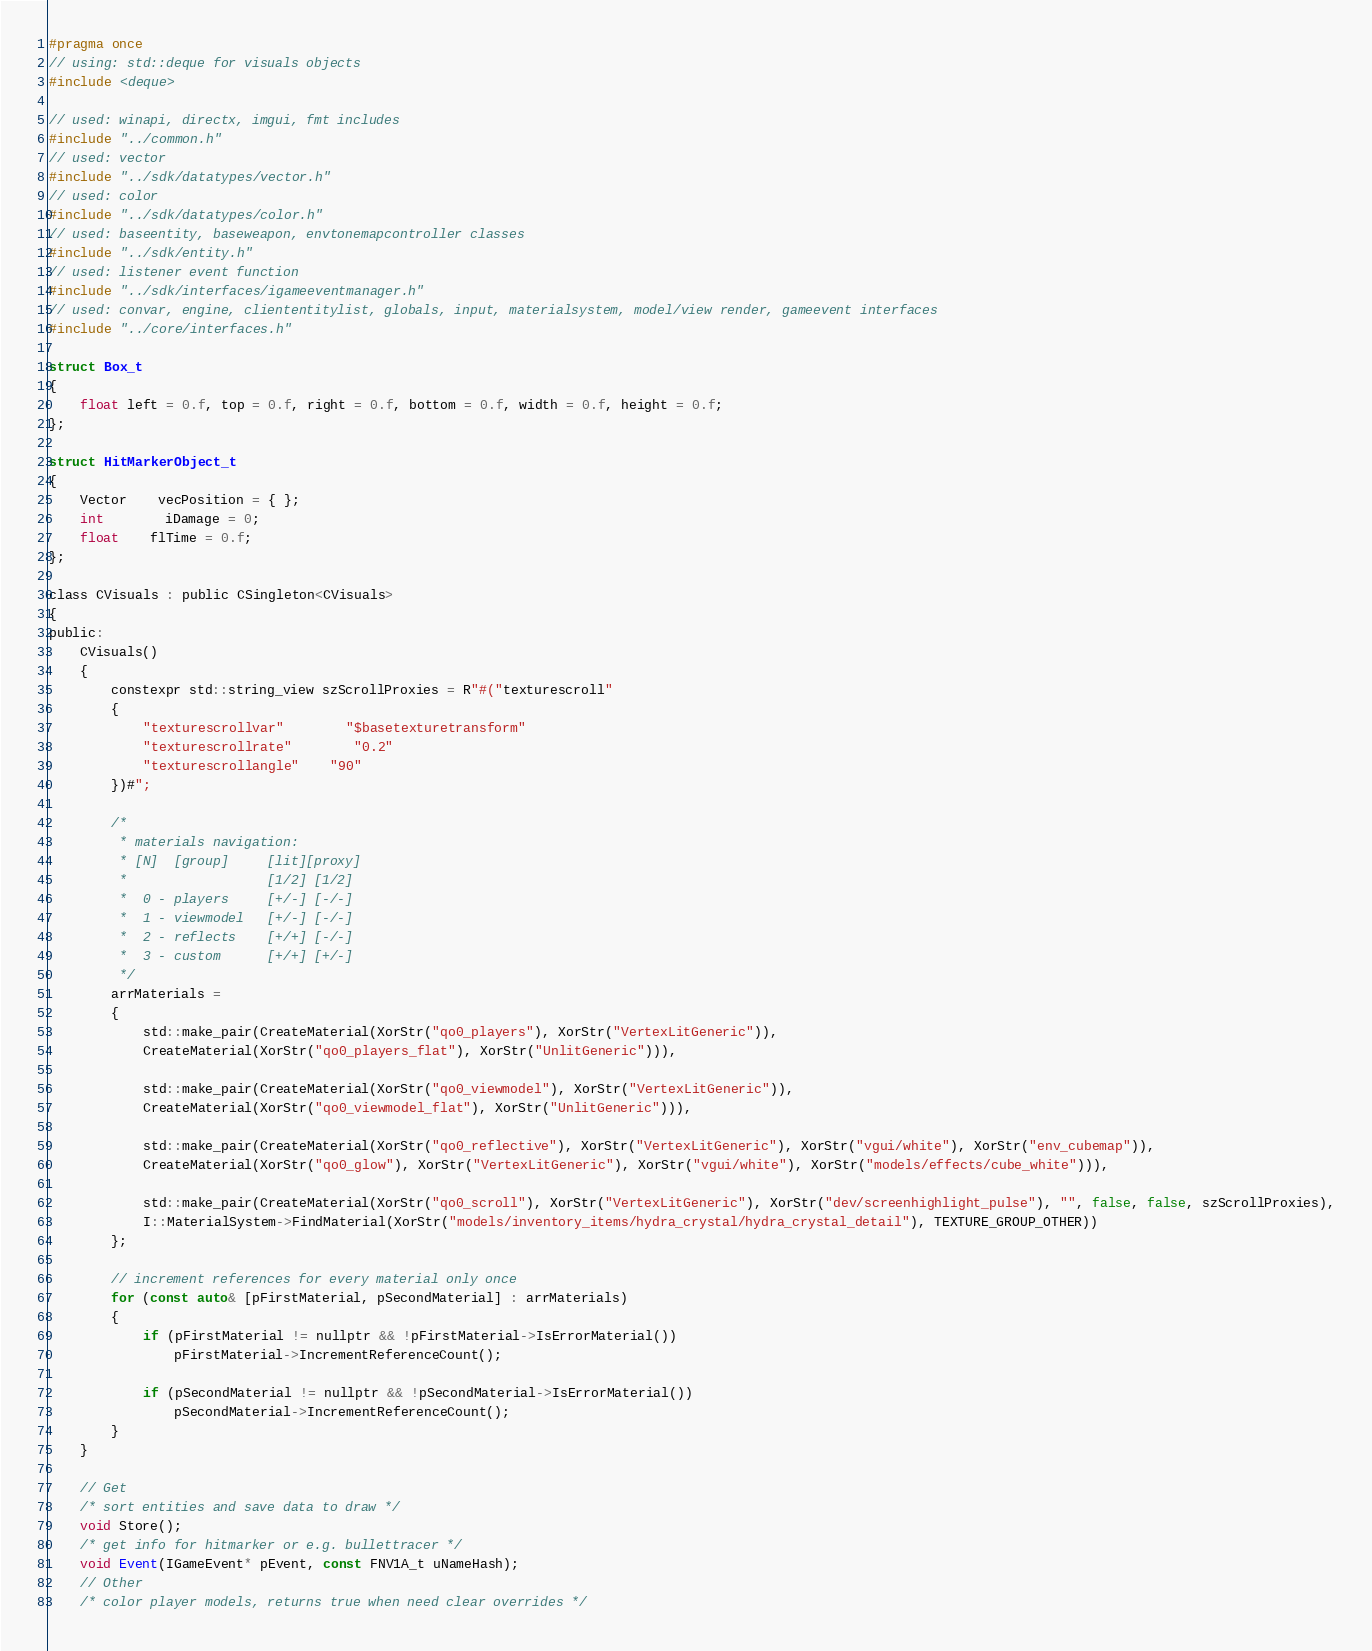<code> <loc_0><loc_0><loc_500><loc_500><_C_>#pragma once
// using: std::deque for visuals objects
#include <deque>

// used: winapi, directx, imgui, fmt includes
#include "../common.h"
// used: vector
#include "../sdk/datatypes/vector.h"
// used: color
#include "../sdk/datatypes/color.h"
// used: baseentity, baseweapon, envtonemapcontroller classes
#include "../sdk/entity.h"
// used: listener event function
#include "../sdk/interfaces/igameeventmanager.h"
// used: convar, engine, cliententitylist, globals, input, materialsystem, model/view render, gameevent interfaces
#include "../core/interfaces.h"

struct Box_t
{
	float left = 0.f, top = 0.f, right = 0.f, bottom = 0.f, width = 0.f, height = 0.f;
};

struct HitMarkerObject_t
{
	Vector	vecPosition = { };
	int		iDamage = 0;
	float	flTime = 0.f;
};

class CVisuals : public CSingleton<CVisuals>
{
public:
	CVisuals()
	{
		constexpr std::string_view szScrollProxies = R"#("texturescroll"
		{
			"texturescrollvar"		"$basetexturetransform"
			"texturescrollrate"		"0.2"
			"texturescrollangle"	"90"
		})#";

		/*
		 * materials navigation:
		 * [N]	[group]		[lit][proxy]
		 *					[1/2] [1/2]
		 *	0 - players		[+/-] [-/-]
		 *	1 - viewmodel	[+/-] [-/-]
		 *	2 - reflects	[+/+] [-/-]
		 *	3 - custom		[+/+] [+/-]
		 */
		arrMaterials =
		{
			std::make_pair(CreateMaterial(XorStr("qo0_players"), XorStr("VertexLitGeneric")),
			CreateMaterial(XorStr("qo0_players_flat"), XorStr("UnlitGeneric"))),

			std::make_pair(CreateMaterial(XorStr("qo0_viewmodel"), XorStr("VertexLitGeneric")),
			CreateMaterial(XorStr("qo0_viewmodel_flat"), XorStr("UnlitGeneric"))),

			std::make_pair(CreateMaterial(XorStr("qo0_reflective"), XorStr("VertexLitGeneric"), XorStr("vgui/white"), XorStr("env_cubemap")),
			CreateMaterial(XorStr("qo0_glow"), XorStr("VertexLitGeneric"), XorStr("vgui/white"), XorStr("models/effects/cube_white"))),

			std::make_pair(CreateMaterial(XorStr("qo0_scroll"), XorStr("VertexLitGeneric"), XorStr("dev/screenhighlight_pulse"), "", false, false, szScrollProxies),
			I::MaterialSystem->FindMaterial(XorStr("models/inventory_items/hydra_crystal/hydra_crystal_detail"), TEXTURE_GROUP_OTHER))
		};

		// increment references for every material only once
		for (const auto& [pFirstMaterial, pSecondMaterial] : arrMaterials)
		{
			if (pFirstMaterial != nullptr && !pFirstMaterial->IsErrorMaterial())
				pFirstMaterial->IncrementReferenceCount();

			if (pSecondMaterial != nullptr && !pSecondMaterial->IsErrorMaterial())
				pSecondMaterial->IncrementReferenceCount();
		}
	}

	// Get
	/* sort entities and save data to draw */
	void Store();
	/* get info for hitmarker or e.g. bullettracer */
	void Event(IGameEvent* pEvent, const FNV1A_t uNameHash);
	// Other
	/* color player models, returns true when need clear overrides */</code> 